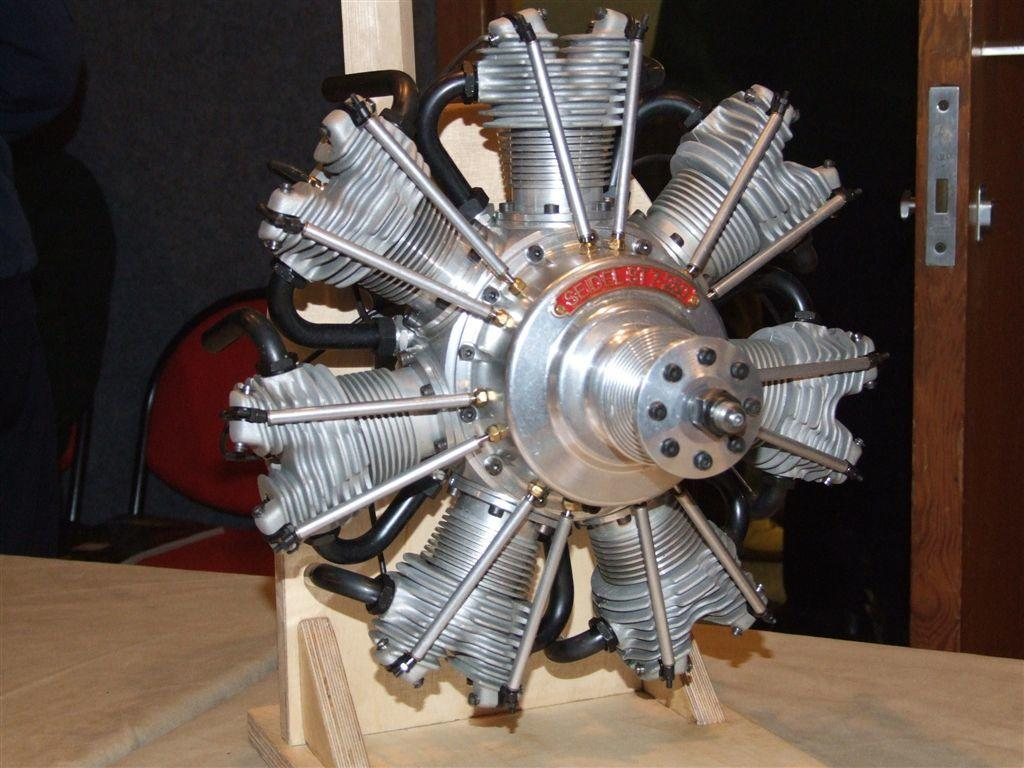What object in the image resembles a fan? There is a metal piece that resembles a fan in the image. How is the metal piece attached to the wood plank? The metal piece is fixed to a wood plank. What can be seen on the right side of the image? There is a door on the right side of the image. What type of thrill can be experienced by the actor in the image? There is no actor present in the image, and therefore no thrill can be experienced. 